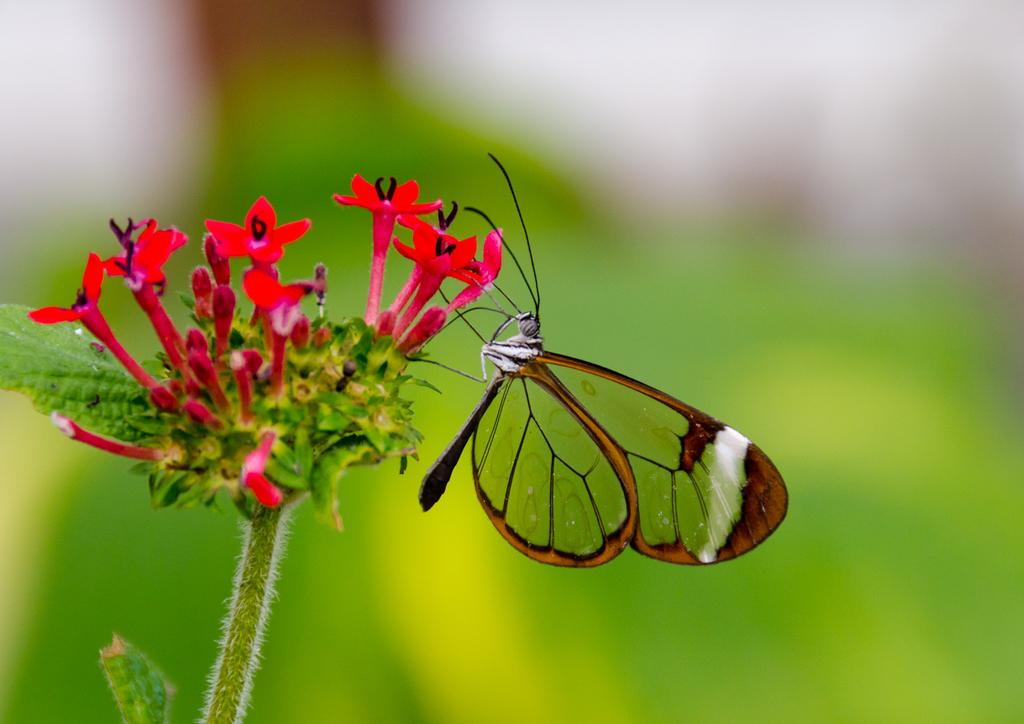What is located in the center of the image? There are leaves and a flower in the center of the image. What color is the flower in the image? The flower is red in color. Is there any other living organism present on the flower? Yes, there is a butterfly on the flower. How many sisters can be seen playing with the fairies in the image? There are no sisters or fairies present in the image; it features a flower with a butterfly on it. Can you tell me the make and model of the airplane visible in the image? There is no airplane present in the image. 